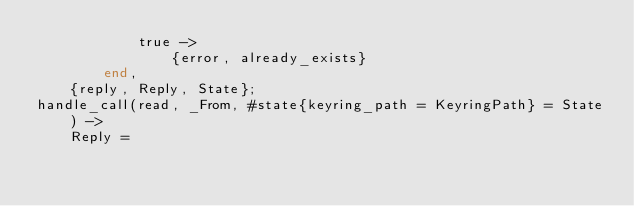Convert code to text. <code><loc_0><loc_0><loc_500><loc_500><_Erlang_>            true ->
                {error, already_exists}
        end,
    {reply, Reply, State};
handle_call(read, _From, #state{keyring_path = KeyringPath} = State) ->
    Reply =</code> 